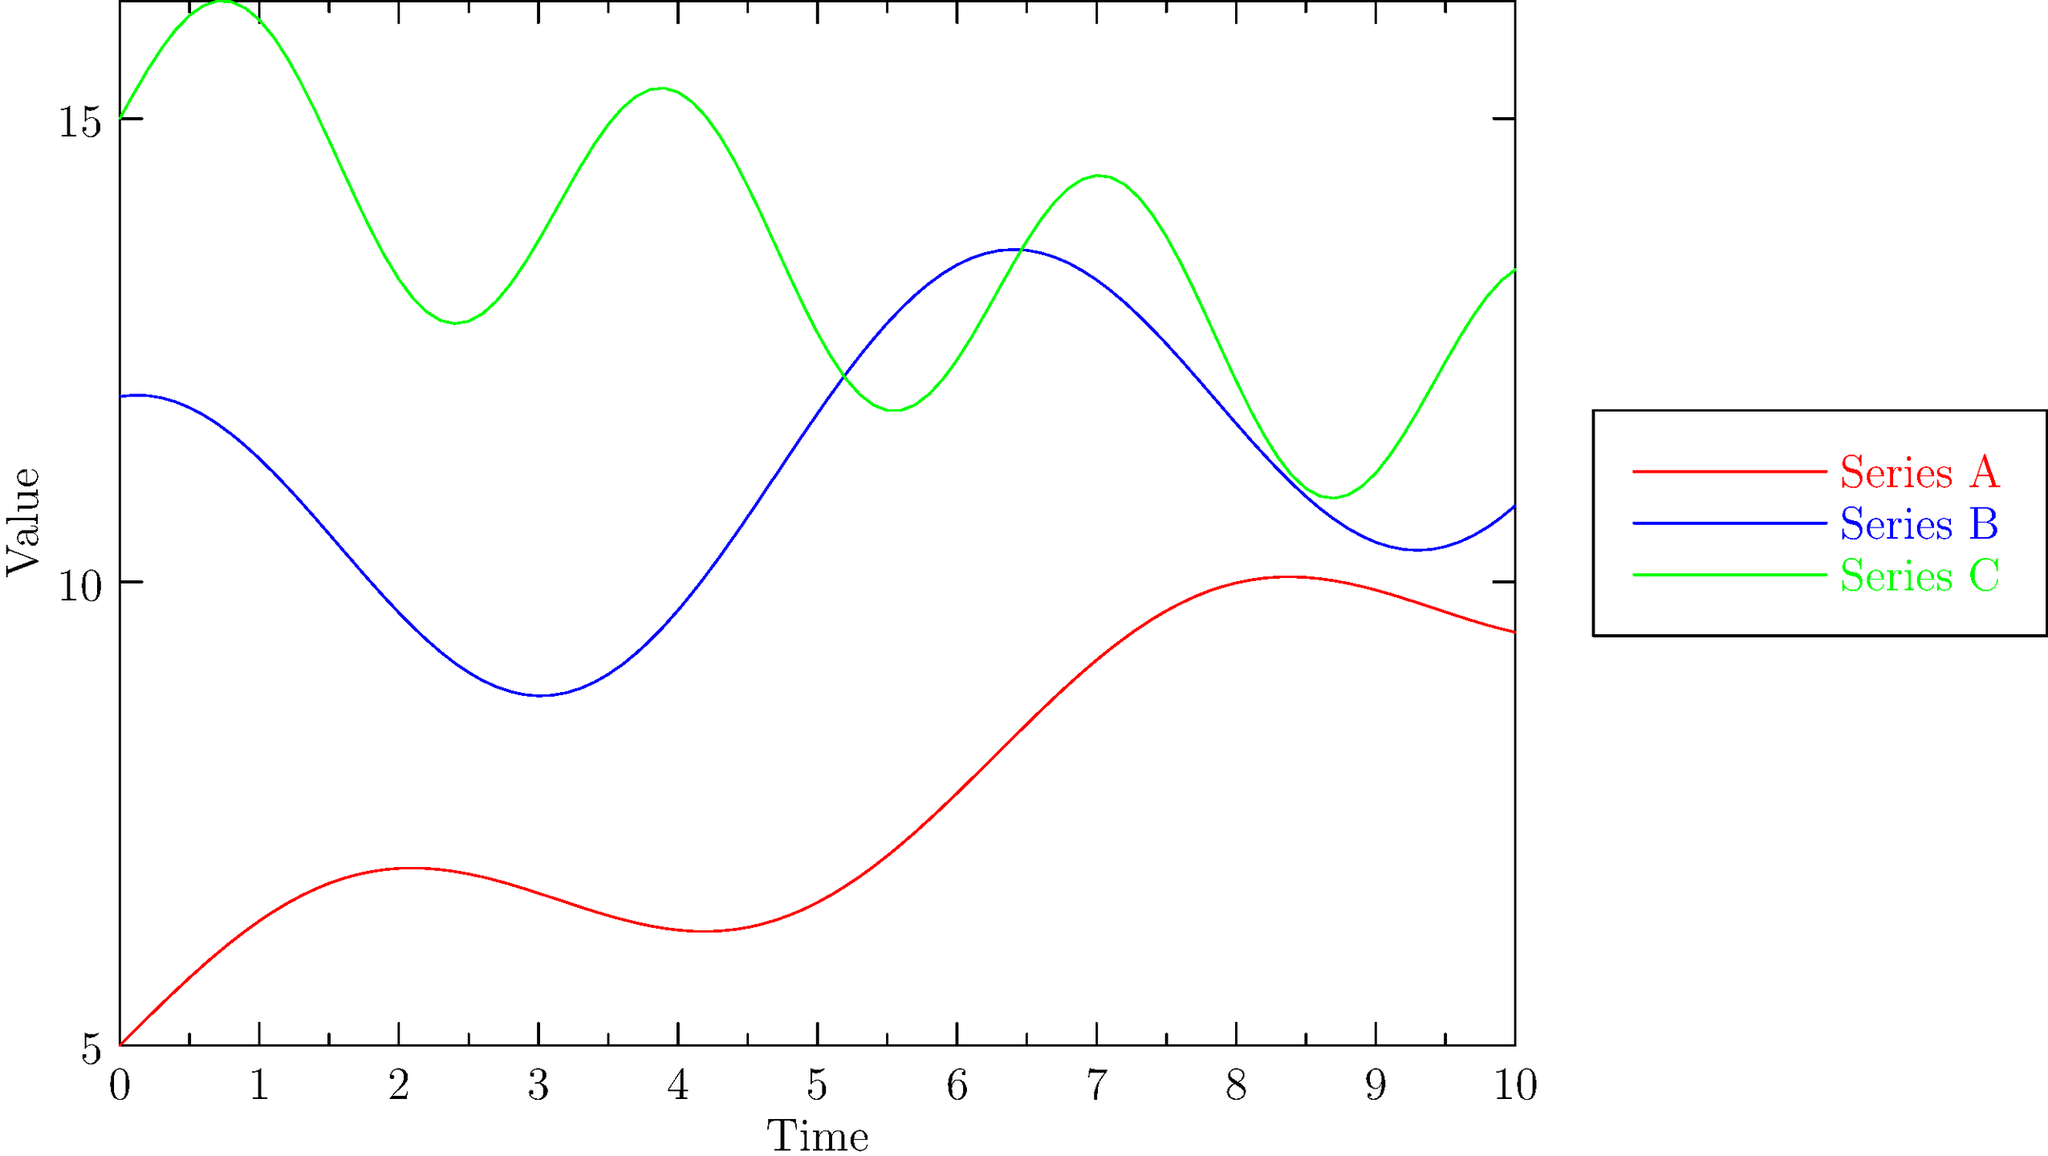Analyze the three time series plots (A, B, and C) shown in the graph. Which series exhibits the strongest overall negative trend, and what unique characteristic does Series B display compared to the others? To answer this question, we need to analyze each series individually:

1. Series A (red):
   - Has a slight positive trend
   - Shows sinusoidal seasonality with a period of approximately $2\pi$

2. Series B (blue):
   - Has a slight positive trend
   - Shows cosinusoidal seasonality with a period of approximately $2\pi$
   - Amplitude of seasonality is larger than Series A

3. Series C (green):
   - Has a clear negative trend
   - Shows sinusoidal seasonality with a period of approximately $\pi$ (twice the frequency of A and B)

To determine the strongest overall negative trend:
- Series A and B have positive trends
- Series C is the only one with a negative trend

Unique characteristic of Series B:
- It's the only series with cosinusoidal seasonality (peaks at the beginning, while A and C start at their mean levels)
- It has the largest amplitude of seasonal fluctuations
Answer: Series C has the strongest negative trend; Series B uniquely exhibits cosinusoidal seasonality with the largest amplitude. 